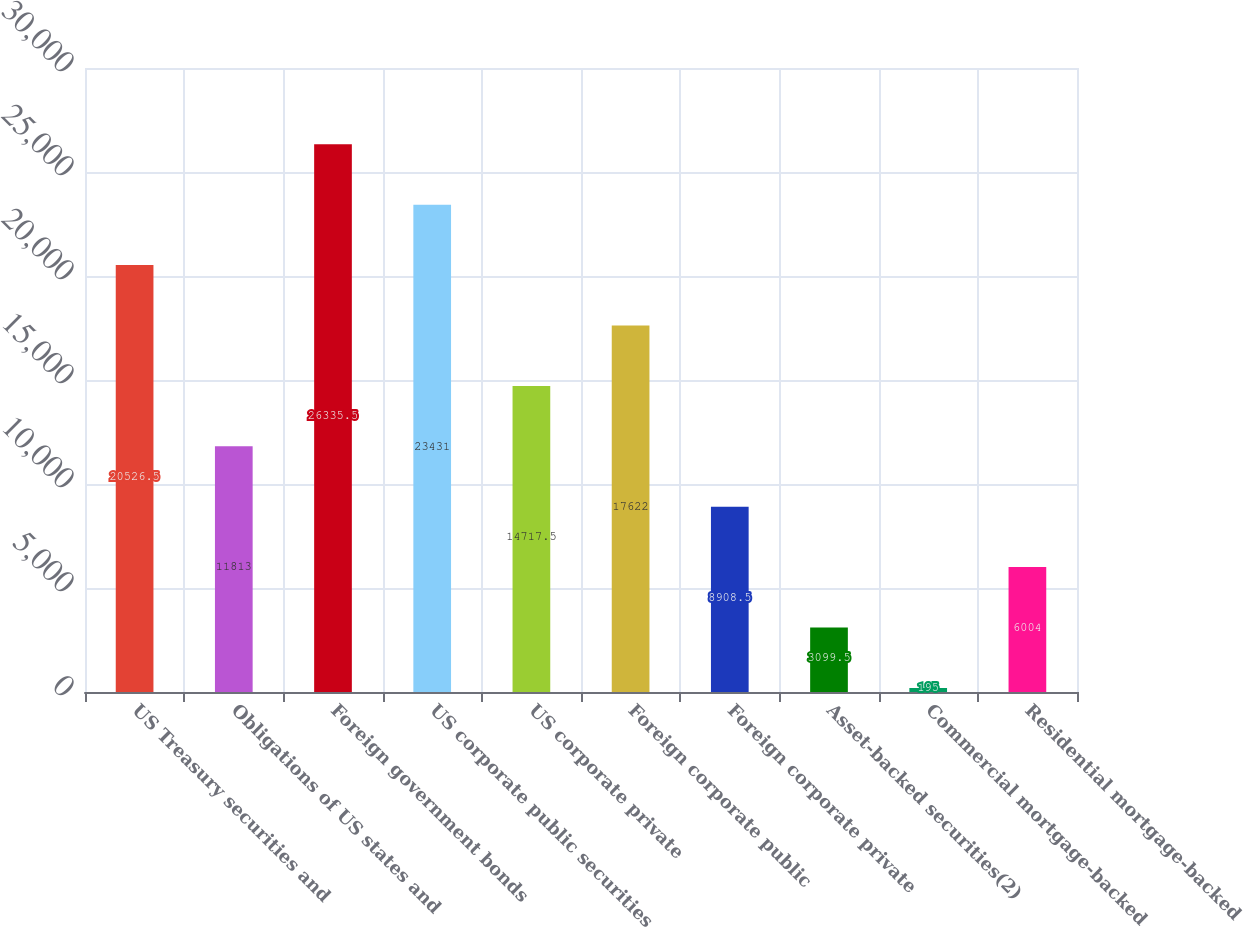<chart> <loc_0><loc_0><loc_500><loc_500><bar_chart><fcel>US Treasury securities and<fcel>Obligations of US states and<fcel>Foreign government bonds<fcel>US corporate public securities<fcel>US corporate private<fcel>Foreign corporate public<fcel>Foreign corporate private<fcel>Asset-backed securities(2)<fcel>Commercial mortgage-backed<fcel>Residential mortgage-backed<nl><fcel>20526.5<fcel>11813<fcel>26335.5<fcel>23431<fcel>14717.5<fcel>17622<fcel>8908.5<fcel>3099.5<fcel>195<fcel>6004<nl></chart> 